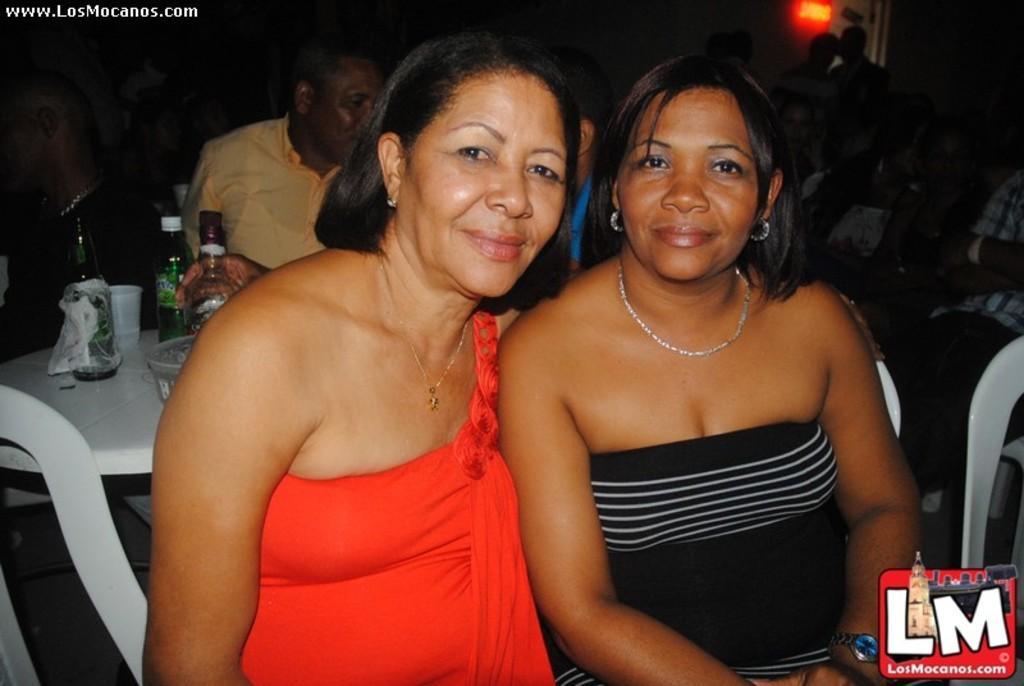How would you summarize this image in a sentence or two? In front of the picture, we see two women are sitting on the chairs. They are smiling and they are posing for the photo. Behind them, we see the people are sitting on the chairs. On the left side, we see a table on which alcohol bottles, water bottle and the glasses are placed. In the background, we see the people are standing. We see a light and a wall in the background. This picture might be clicked in the dark. 